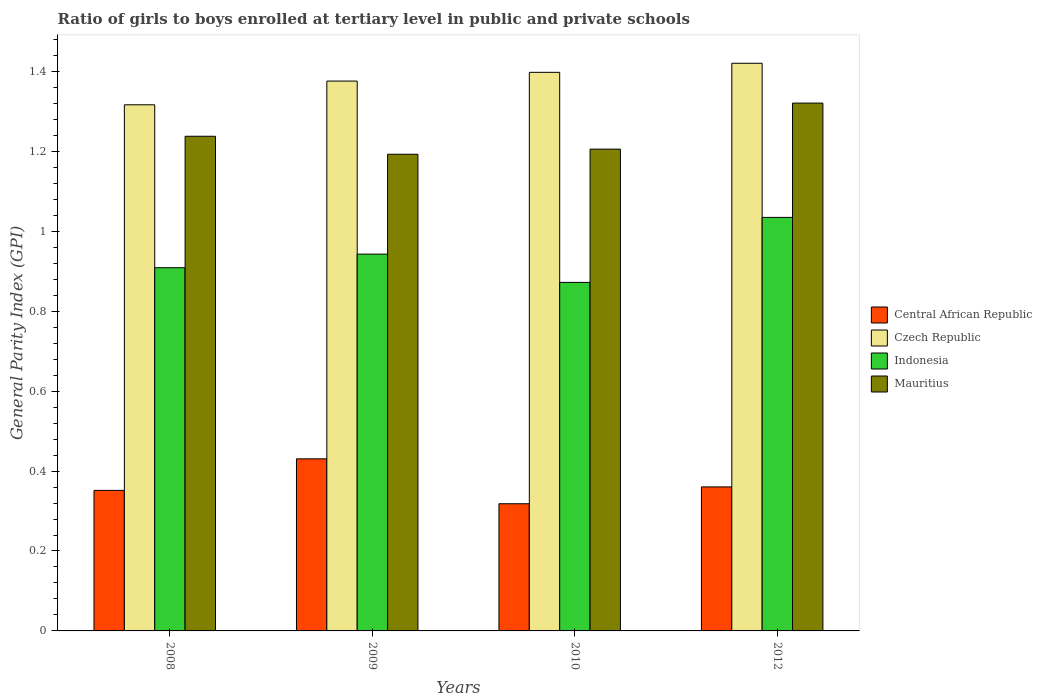How many different coloured bars are there?
Give a very brief answer. 4. How many groups of bars are there?
Offer a very short reply. 4. How many bars are there on the 1st tick from the left?
Your answer should be compact. 4. What is the label of the 4th group of bars from the left?
Your answer should be very brief. 2012. What is the general parity index in Central African Republic in 2009?
Offer a very short reply. 0.43. Across all years, what is the maximum general parity index in Indonesia?
Keep it short and to the point. 1.03. Across all years, what is the minimum general parity index in Czech Republic?
Provide a short and direct response. 1.32. What is the total general parity index in Mauritius in the graph?
Your answer should be compact. 4.96. What is the difference between the general parity index in Mauritius in 2008 and that in 2012?
Make the answer very short. -0.08. What is the difference between the general parity index in Mauritius in 2008 and the general parity index in Czech Republic in 2009?
Make the answer very short. -0.14. What is the average general parity index in Central African Republic per year?
Ensure brevity in your answer.  0.37. In the year 2008, what is the difference between the general parity index in Czech Republic and general parity index in Indonesia?
Provide a short and direct response. 0.41. What is the ratio of the general parity index in Mauritius in 2008 to that in 2012?
Provide a succinct answer. 0.94. Is the general parity index in Mauritius in 2008 less than that in 2009?
Offer a very short reply. No. Is the difference between the general parity index in Czech Republic in 2008 and 2009 greater than the difference between the general parity index in Indonesia in 2008 and 2009?
Your answer should be very brief. No. What is the difference between the highest and the second highest general parity index in Indonesia?
Give a very brief answer. 0.09. What is the difference between the highest and the lowest general parity index in Indonesia?
Your answer should be compact. 0.16. In how many years, is the general parity index in Czech Republic greater than the average general parity index in Czech Republic taken over all years?
Make the answer very short. 2. Is it the case that in every year, the sum of the general parity index in Mauritius and general parity index in Indonesia is greater than the sum of general parity index in Central African Republic and general parity index in Czech Republic?
Offer a terse response. Yes. What does the 1st bar from the left in 2010 represents?
Make the answer very short. Central African Republic. What does the 4th bar from the right in 2012 represents?
Give a very brief answer. Central African Republic. Are all the bars in the graph horizontal?
Your answer should be very brief. No. Are the values on the major ticks of Y-axis written in scientific E-notation?
Provide a short and direct response. No. What is the title of the graph?
Your answer should be very brief. Ratio of girls to boys enrolled at tertiary level in public and private schools. What is the label or title of the X-axis?
Provide a succinct answer. Years. What is the label or title of the Y-axis?
Give a very brief answer. General Parity Index (GPI). What is the General Parity Index (GPI) in Central African Republic in 2008?
Make the answer very short. 0.35. What is the General Parity Index (GPI) of Czech Republic in 2008?
Ensure brevity in your answer.  1.32. What is the General Parity Index (GPI) of Indonesia in 2008?
Keep it short and to the point. 0.91. What is the General Parity Index (GPI) of Mauritius in 2008?
Provide a short and direct response. 1.24. What is the General Parity Index (GPI) of Central African Republic in 2009?
Offer a very short reply. 0.43. What is the General Parity Index (GPI) of Czech Republic in 2009?
Offer a very short reply. 1.38. What is the General Parity Index (GPI) of Indonesia in 2009?
Make the answer very short. 0.94. What is the General Parity Index (GPI) of Mauritius in 2009?
Your response must be concise. 1.19. What is the General Parity Index (GPI) of Central African Republic in 2010?
Make the answer very short. 0.32. What is the General Parity Index (GPI) in Czech Republic in 2010?
Ensure brevity in your answer.  1.4. What is the General Parity Index (GPI) of Indonesia in 2010?
Keep it short and to the point. 0.87. What is the General Parity Index (GPI) in Mauritius in 2010?
Make the answer very short. 1.21. What is the General Parity Index (GPI) in Central African Republic in 2012?
Make the answer very short. 0.36. What is the General Parity Index (GPI) of Czech Republic in 2012?
Provide a short and direct response. 1.42. What is the General Parity Index (GPI) of Indonesia in 2012?
Offer a very short reply. 1.03. What is the General Parity Index (GPI) in Mauritius in 2012?
Provide a succinct answer. 1.32. Across all years, what is the maximum General Parity Index (GPI) in Central African Republic?
Your response must be concise. 0.43. Across all years, what is the maximum General Parity Index (GPI) in Czech Republic?
Provide a short and direct response. 1.42. Across all years, what is the maximum General Parity Index (GPI) of Indonesia?
Keep it short and to the point. 1.03. Across all years, what is the maximum General Parity Index (GPI) of Mauritius?
Your answer should be compact. 1.32. Across all years, what is the minimum General Parity Index (GPI) of Central African Republic?
Provide a succinct answer. 0.32. Across all years, what is the minimum General Parity Index (GPI) of Czech Republic?
Provide a short and direct response. 1.32. Across all years, what is the minimum General Parity Index (GPI) of Indonesia?
Offer a very short reply. 0.87. Across all years, what is the minimum General Parity Index (GPI) of Mauritius?
Your answer should be very brief. 1.19. What is the total General Parity Index (GPI) in Central African Republic in the graph?
Offer a very short reply. 1.46. What is the total General Parity Index (GPI) of Czech Republic in the graph?
Provide a short and direct response. 5.51. What is the total General Parity Index (GPI) in Indonesia in the graph?
Your answer should be very brief. 3.76. What is the total General Parity Index (GPI) in Mauritius in the graph?
Your answer should be compact. 4.96. What is the difference between the General Parity Index (GPI) in Central African Republic in 2008 and that in 2009?
Provide a short and direct response. -0.08. What is the difference between the General Parity Index (GPI) in Czech Republic in 2008 and that in 2009?
Offer a very short reply. -0.06. What is the difference between the General Parity Index (GPI) of Indonesia in 2008 and that in 2009?
Make the answer very short. -0.03. What is the difference between the General Parity Index (GPI) in Mauritius in 2008 and that in 2009?
Ensure brevity in your answer.  0.04. What is the difference between the General Parity Index (GPI) of Central African Republic in 2008 and that in 2010?
Your response must be concise. 0.03. What is the difference between the General Parity Index (GPI) in Czech Republic in 2008 and that in 2010?
Offer a terse response. -0.08. What is the difference between the General Parity Index (GPI) in Indonesia in 2008 and that in 2010?
Your answer should be compact. 0.04. What is the difference between the General Parity Index (GPI) in Mauritius in 2008 and that in 2010?
Give a very brief answer. 0.03. What is the difference between the General Parity Index (GPI) of Central African Republic in 2008 and that in 2012?
Make the answer very short. -0.01. What is the difference between the General Parity Index (GPI) of Czech Republic in 2008 and that in 2012?
Provide a succinct answer. -0.1. What is the difference between the General Parity Index (GPI) in Indonesia in 2008 and that in 2012?
Offer a terse response. -0.13. What is the difference between the General Parity Index (GPI) of Mauritius in 2008 and that in 2012?
Ensure brevity in your answer.  -0.08. What is the difference between the General Parity Index (GPI) of Central African Republic in 2009 and that in 2010?
Make the answer very short. 0.11. What is the difference between the General Parity Index (GPI) of Czech Republic in 2009 and that in 2010?
Your answer should be compact. -0.02. What is the difference between the General Parity Index (GPI) in Indonesia in 2009 and that in 2010?
Your answer should be very brief. 0.07. What is the difference between the General Parity Index (GPI) in Mauritius in 2009 and that in 2010?
Ensure brevity in your answer.  -0.01. What is the difference between the General Parity Index (GPI) in Central African Republic in 2009 and that in 2012?
Make the answer very short. 0.07. What is the difference between the General Parity Index (GPI) of Czech Republic in 2009 and that in 2012?
Make the answer very short. -0.04. What is the difference between the General Parity Index (GPI) of Indonesia in 2009 and that in 2012?
Provide a succinct answer. -0.09. What is the difference between the General Parity Index (GPI) in Mauritius in 2009 and that in 2012?
Provide a succinct answer. -0.13. What is the difference between the General Parity Index (GPI) of Central African Republic in 2010 and that in 2012?
Your response must be concise. -0.04. What is the difference between the General Parity Index (GPI) in Czech Republic in 2010 and that in 2012?
Ensure brevity in your answer.  -0.02. What is the difference between the General Parity Index (GPI) of Indonesia in 2010 and that in 2012?
Your response must be concise. -0.16. What is the difference between the General Parity Index (GPI) of Mauritius in 2010 and that in 2012?
Give a very brief answer. -0.12. What is the difference between the General Parity Index (GPI) in Central African Republic in 2008 and the General Parity Index (GPI) in Czech Republic in 2009?
Ensure brevity in your answer.  -1.02. What is the difference between the General Parity Index (GPI) of Central African Republic in 2008 and the General Parity Index (GPI) of Indonesia in 2009?
Offer a terse response. -0.59. What is the difference between the General Parity Index (GPI) of Central African Republic in 2008 and the General Parity Index (GPI) of Mauritius in 2009?
Provide a succinct answer. -0.84. What is the difference between the General Parity Index (GPI) in Czech Republic in 2008 and the General Parity Index (GPI) in Indonesia in 2009?
Your answer should be compact. 0.37. What is the difference between the General Parity Index (GPI) of Czech Republic in 2008 and the General Parity Index (GPI) of Mauritius in 2009?
Provide a succinct answer. 0.12. What is the difference between the General Parity Index (GPI) in Indonesia in 2008 and the General Parity Index (GPI) in Mauritius in 2009?
Your answer should be very brief. -0.28. What is the difference between the General Parity Index (GPI) in Central African Republic in 2008 and the General Parity Index (GPI) in Czech Republic in 2010?
Keep it short and to the point. -1.05. What is the difference between the General Parity Index (GPI) of Central African Republic in 2008 and the General Parity Index (GPI) of Indonesia in 2010?
Your response must be concise. -0.52. What is the difference between the General Parity Index (GPI) of Central African Republic in 2008 and the General Parity Index (GPI) of Mauritius in 2010?
Ensure brevity in your answer.  -0.85. What is the difference between the General Parity Index (GPI) in Czech Republic in 2008 and the General Parity Index (GPI) in Indonesia in 2010?
Ensure brevity in your answer.  0.44. What is the difference between the General Parity Index (GPI) of Czech Republic in 2008 and the General Parity Index (GPI) of Mauritius in 2010?
Give a very brief answer. 0.11. What is the difference between the General Parity Index (GPI) of Indonesia in 2008 and the General Parity Index (GPI) of Mauritius in 2010?
Keep it short and to the point. -0.3. What is the difference between the General Parity Index (GPI) in Central African Republic in 2008 and the General Parity Index (GPI) in Czech Republic in 2012?
Provide a short and direct response. -1.07. What is the difference between the General Parity Index (GPI) in Central African Republic in 2008 and the General Parity Index (GPI) in Indonesia in 2012?
Ensure brevity in your answer.  -0.68. What is the difference between the General Parity Index (GPI) of Central African Republic in 2008 and the General Parity Index (GPI) of Mauritius in 2012?
Your response must be concise. -0.97. What is the difference between the General Parity Index (GPI) in Czech Republic in 2008 and the General Parity Index (GPI) in Indonesia in 2012?
Provide a short and direct response. 0.28. What is the difference between the General Parity Index (GPI) of Czech Republic in 2008 and the General Parity Index (GPI) of Mauritius in 2012?
Keep it short and to the point. -0. What is the difference between the General Parity Index (GPI) of Indonesia in 2008 and the General Parity Index (GPI) of Mauritius in 2012?
Make the answer very short. -0.41. What is the difference between the General Parity Index (GPI) of Central African Republic in 2009 and the General Parity Index (GPI) of Czech Republic in 2010?
Make the answer very short. -0.97. What is the difference between the General Parity Index (GPI) of Central African Republic in 2009 and the General Parity Index (GPI) of Indonesia in 2010?
Give a very brief answer. -0.44. What is the difference between the General Parity Index (GPI) in Central African Republic in 2009 and the General Parity Index (GPI) in Mauritius in 2010?
Your answer should be very brief. -0.77. What is the difference between the General Parity Index (GPI) of Czech Republic in 2009 and the General Parity Index (GPI) of Indonesia in 2010?
Keep it short and to the point. 0.5. What is the difference between the General Parity Index (GPI) in Czech Republic in 2009 and the General Parity Index (GPI) in Mauritius in 2010?
Your answer should be very brief. 0.17. What is the difference between the General Parity Index (GPI) in Indonesia in 2009 and the General Parity Index (GPI) in Mauritius in 2010?
Offer a terse response. -0.26. What is the difference between the General Parity Index (GPI) in Central African Republic in 2009 and the General Parity Index (GPI) in Czech Republic in 2012?
Make the answer very short. -0.99. What is the difference between the General Parity Index (GPI) of Central African Republic in 2009 and the General Parity Index (GPI) of Indonesia in 2012?
Provide a short and direct response. -0.6. What is the difference between the General Parity Index (GPI) in Central African Republic in 2009 and the General Parity Index (GPI) in Mauritius in 2012?
Provide a short and direct response. -0.89. What is the difference between the General Parity Index (GPI) of Czech Republic in 2009 and the General Parity Index (GPI) of Indonesia in 2012?
Keep it short and to the point. 0.34. What is the difference between the General Parity Index (GPI) of Czech Republic in 2009 and the General Parity Index (GPI) of Mauritius in 2012?
Make the answer very short. 0.06. What is the difference between the General Parity Index (GPI) in Indonesia in 2009 and the General Parity Index (GPI) in Mauritius in 2012?
Give a very brief answer. -0.38. What is the difference between the General Parity Index (GPI) in Central African Republic in 2010 and the General Parity Index (GPI) in Czech Republic in 2012?
Provide a short and direct response. -1.1. What is the difference between the General Parity Index (GPI) of Central African Republic in 2010 and the General Parity Index (GPI) of Indonesia in 2012?
Make the answer very short. -0.72. What is the difference between the General Parity Index (GPI) of Central African Republic in 2010 and the General Parity Index (GPI) of Mauritius in 2012?
Offer a very short reply. -1. What is the difference between the General Parity Index (GPI) of Czech Republic in 2010 and the General Parity Index (GPI) of Indonesia in 2012?
Offer a very short reply. 0.36. What is the difference between the General Parity Index (GPI) of Czech Republic in 2010 and the General Parity Index (GPI) of Mauritius in 2012?
Keep it short and to the point. 0.08. What is the difference between the General Parity Index (GPI) of Indonesia in 2010 and the General Parity Index (GPI) of Mauritius in 2012?
Keep it short and to the point. -0.45. What is the average General Parity Index (GPI) of Central African Republic per year?
Make the answer very short. 0.37. What is the average General Parity Index (GPI) in Czech Republic per year?
Give a very brief answer. 1.38. What is the average General Parity Index (GPI) in Indonesia per year?
Offer a very short reply. 0.94. What is the average General Parity Index (GPI) in Mauritius per year?
Provide a short and direct response. 1.24. In the year 2008, what is the difference between the General Parity Index (GPI) in Central African Republic and General Parity Index (GPI) in Czech Republic?
Offer a very short reply. -0.96. In the year 2008, what is the difference between the General Parity Index (GPI) in Central African Republic and General Parity Index (GPI) in Indonesia?
Ensure brevity in your answer.  -0.56. In the year 2008, what is the difference between the General Parity Index (GPI) in Central African Republic and General Parity Index (GPI) in Mauritius?
Make the answer very short. -0.89. In the year 2008, what is the difference between the General Parity Index (GPI) in Czech Republic and General Parity Index (GPI) in Indonesia?
Ensure brevity in your answer.  0.41. In the year 2008, what is the difference between the General Parity Index (GPI) in Czech Republic and General Parity Index (GPI) in Mauritius?
Keep it short and to the point. 0.08. In the year 2008, what is the difference between the General Parity Index (GPI) of Indonesia and General Parity Index (GPI) of Mauritius?
Your answer should be compact. -0.33. In the year 2009, what is the difference between the General Parity Index (GPI) in Central African Republic and General Parity Index (GPI) in Czech Republic?
Provide a succinct answer. -0.95. In the year 2009, what is the difference between the General Parity Index (GPI) of Central African Republic and General Parity Index (GPI) of Indonesia?
Offer a terse response. -0.51. In the year 2009, what is the difference between the General Parity Index (GPI) in Central African Republic and General Parity Index (GPI) in Mauritius?
Give a very brief answer. -0.76. In the year 2009, what is the difference between the General Parity Index (GPI) in Czech Republic and General Parity Index (GPI) in Indonesia?
Give a very brief answer. 0.43. In the year 2009, what is the difference between the General Parity Index (GPI) of Czech Republic and General Parity Index (GPI) of Mauritius?
Provide a succinct answer. 0.18. In the year 2009, what is the difference between the General Parity Index (GPI) of Indonesia and General Parity Index (GPI) of Mauritius?
Your answer should be very brief. -0.25. In the year 2010, what is the difference between the General Parity Index (GPI) of Central African Republic and General Parity Index (GPI) of Czech Republic?
Offer a terse response. -1.08. In the year 2010, what is the difference between the General Parity Index (GPI) of Central African Republic and General Parity Index (GPI) of Indonesia?
Provide a short and direct response. -0.55. In the year 2010, what is the difference between the General Parity Index (GPI) in Central African Republic and General Parity Index (GPI) in Mauritius?
Provide a short and direct response. -0.89. In the year 2010, what is the difference between the General Parity Index (GPI) in Czech Republic and General Parity Index (GPI) in Indonesia?
Provide a short and direct response. 0.53. In the year 2010, what is the difference between the General Parity Index (GPI) in Czech Republic and General Parity Index (GPI) in Mauritius?
Ensure brevity in your answer.  0.19. In the year 2010, what is the difference between the General Parity Index (GPI) of Indonesia and General Parity Index (GPI) of Mauritius?
Ensure brevity in your answer.  -0.33. In the year 2012, what is the difference between the General Parity Index (GPI) in Central African Republic and General Parity Index (GPI) in Czech Republic?
Ensure brevity in your answer.  -1.06. In the year 2012, what is the difference between the General Parity Index (GPI) of Central African Republic and General Parity Index (GPI) of Indonesia?
Ensure brevity in your answer.  -0.67. In the year 2012, what is the difference between the General Parity Index (GPI) of Central African Republic and General Parity Index (GPI) of Mauritius?
Provide a short and direct response. -0.96. In the year 2012, what is the difference between the General Parity Index (GPI) of Czech Republic and General Parity Index (GPI) of Indonesia?
Keep it short and to the point. 0.39. In the year 2012, what is the difference between the General Parity Index (GPI) of Czech Republic and General Parity Index (GPI) of Mauritius?
Provide a succinct answer. 0.1. In the year 2012, what is the difference between the General Parity Index (GPI) in Indonesia and General Parity Index (GPI) in Mauritius?
Keep it short and to the point. -0.29. What is the ratio of the General Parity Index (GPI) in Central African Republic in 2008 to that in 2009?
Offer a terse response. 0.82. What is the ratio of the General Parity Index (GPI) of Czech Republic in 2008 to that in 2009?
Provide a short and direct response. 0.96. What is the ratio of the General Parity Index (GPI) of Indonesia in 2008 to that in 2009?
Provide a short and direct response. 0.96. What is the ratio of the General Parity Index (GPI) of Mauritius in 2008 to that in 2009?
Provide a short and direct response. 1.04. What is the ratio of the General Parity Index (GPI) of Central African Republic in 2008 to that in 2010?
Your response must be concise. 1.11. What is the ratio of the General Parity Index (GPI) in Czech Republic in 2008 to that in 2010?
Make the answer very short. 0.94. What is the ratio of the General Parity Index (GPI) of Indonesia in 2008 to that in 2010?
Make the answer very short. 1.04. What is the ratio of the General Parity Index (GPI) of Mauritius in 2008 to that in 2010?
Your answer should be compact. 1.03. What is the ratio of the General Parity Index (GPI) of Central African Republic in 2008 to that in 2012?
Offer a very short reply. 0.98. What is the ratio of the General Parity Index (GPI) in Czech Republic in 2008 to that in 2012?
Offer a very short reply. 0.93. What is the ratio of the General Parity Index (GPI) of Indonesia in 2008 to that in 2012?
Ensure brevity in your answer.  0.88. What is the ratio of the General Parity Index (GPI) of Mauritius in 2008 to that in 2012?
Your response must be concise. 0.94. What is the ratio of the General Parity Index (GPI) of Central African Republic in 2009 to that in 2010?
Provide a succinct answer. 1.35. What is the ratio of the General Parity Index (GPI) of Czech Republic in 2009 to that in 2010?
Offer a terse response. 0.98. What is the ratio of the General Parity Index (GPI) in Indonesia in 2009 to that in 2010?
Your response must be concise. 1.08. What is the ratio of the General Parity Index (GPI) in Mauritius in 2009 to that in 2010?
Offer a terse response. 0.99. What is the ratio of the General Parity Index (GPI) of Central African Republic in 2009 to that in 2012?
Offer a terse response. 1.19. What is the ratio of the General Parity Index (GPI) in Czech Republic in 2009 to that in 2012?
Your response must be concise. 0.97. What is the ratio of the General Parity Index (GPI) in Indonesia in 2009 to that in 2012?
Provide a short and direct response. 0.91. What is the ratio of the General Parity Index (GPI) in Mauritius in 2009 to that in 2012?
Your answer should be very brief. 0.9. What is the ratio of the General Parity Index (GPI) of Central African Republic in 2010 to that in 2012?
Offer a terse response. 0.88. What is the ratio of the General Parity Index (GPI) of Indonesia in 2010 to that in 2012?
Offer a terse response. 0.84. What is the ratio of the General Parity Index (GPI) of Mauritius in 2010 to that in 2012?
Offer a very short reply. 0.91. What is the difference between the highest and the second highest General Parity Index (GPI) in Central African Republic?
Your answer should be compact. 0.07. What is the difference between the highest and the second highest General Parity Index (GPI) in Czech Republic?
Your answer should be very brief. 0.02. What is the difference between the highest and the second highest General Parity Index (GPI) of Indonesia?
Your response must be concise. 0.09. What is the difference between the highest and the second highest General Parity Index (GPI) of Mauritius?
Your answer should be compact. 0.08. What is the difference between the highest and the lowest General Parity Index (GPI) of Central African Republic?
Give a very brief answer. 0.11. What is the difference between the highest and the lowest General Parity Index (GPI) of Czech Republic?
Provide a short and direct response. 0.1. What is the difference between the highest and the lowest General Parity Index (GPI) in Indonesia?
Give a very brief answer. 0.16. What is the difference between the highest and the lowest General Parity Index (GPI) in Mauritius?
Your response must be concise. 0.13. 